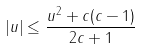<formula> <loc_0><loc_0><loc_500><loc_500>| u | \leq \frac { u ^ { 2 } + c ( c - 1 ) } { 2 c + 1 }</formula> 